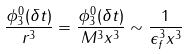Convert formula to latex. <formula><loc_0><loc_0><loc_500><loc_500>\frac { \phi ^ { 0 } _ { 3 } ( \delta t ) } { r ^ { 3 } } = \frac { \phi ^ { 0 } _ { 3 } ( \delta t ) } { M ^ { 3 } x ^ { 3 } } \sim \frac { 1 } { \epsilon _ { f } ^ { 3 } x ^ { 3 } }</formula> 